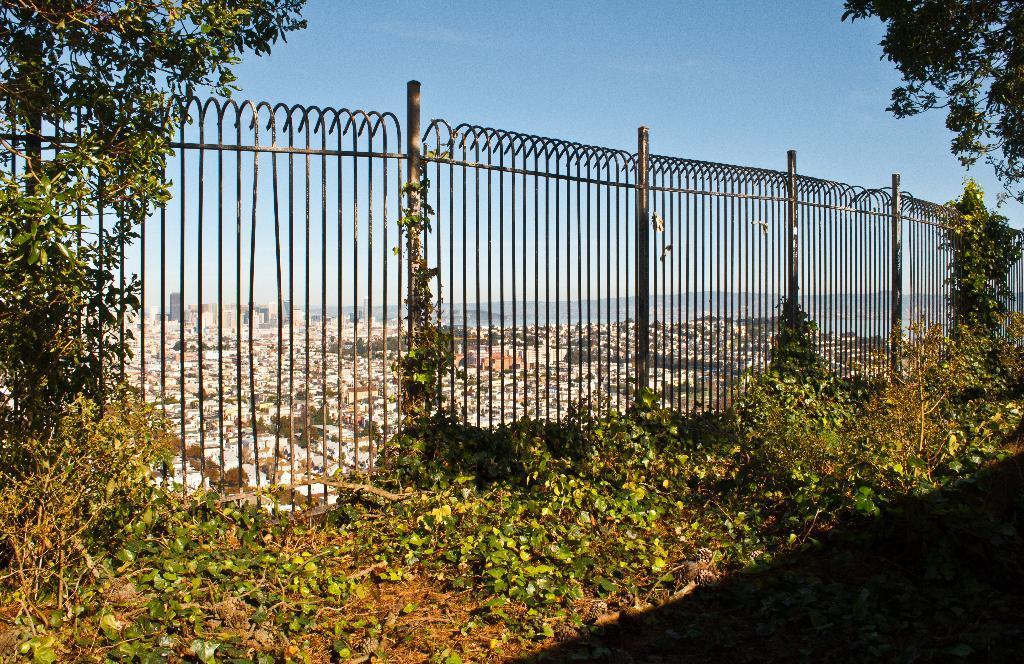Can you describe this image briefly? In this image, we can see a fence and there are some green plants and trees, at the top there is a blue sky. 